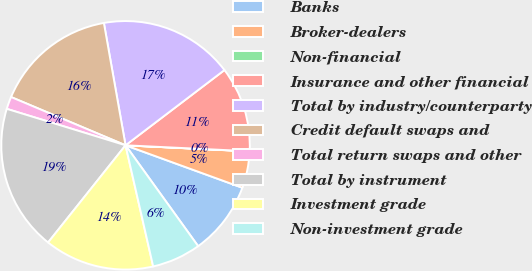<chart> <loc_0><loc_0><loc_500><loc_500><pie_chart><fcel>Banks<fcel>Broker-dealers<fcel>Non-financial<fcel>Insurance and other financial<fcel>Total by industry/counterparty<fcel>Credit default swaps and<fcel>Total return swaps and other<fcel>Total by instrument<fcel>Investment grade<fcel>Non-investment grade<nl><fcel>9.52%<fcel>4.77%<fcel>0.02%<fcel>11.11%<fcel>17.44%<fcel>15.86%<fcel>1.61%<fcel>19.03%<fcel>14.28%<fcel>6.36%<nl></chart> 